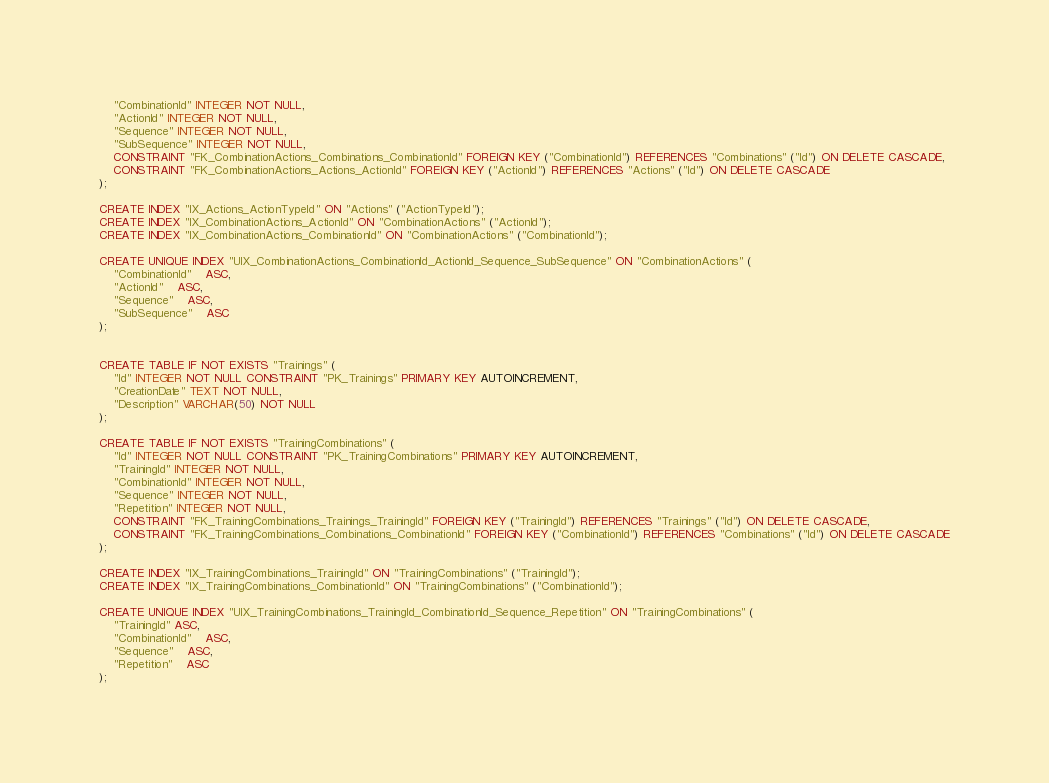<code> <loc_0><loc_0><loc_500><loc_500><_SQL_>    "CombinationId" INTEGER NOT NULL,
    "ActionId" INTEGER NOT NULL,
    "Sequence" INTEGER NOT NULL,
    "SubSequence" INTEGER NOT NULL,
    CONSTRAINT "FK_CombinationActions_Combinations_CombinationId" FOREIGN KEY ("CombinationId") REFERENCES "Combinations" ("Id") ON DELETE CASCADE,
    CONSTRAINT "FK_CombinationActions_Actions_ActionId" FOREIGN KEY ("ActionId") REFERENCES "Actions" ("Id") ON DELETE CASCADE
);

CREATE INDEX "IX_Actions_ActionTypeId" ON "Actions" ("ActionTypeId");
CREATE INDEX "IX_CombinationActions_ActionId" ON "CombinationActions" ("ActionId");
CREATE INDEX "IX_CombinationActions_CombinationId" ON "CombinationActions" ("CombinationId");

CREATE UNIQUE INDEX "UIX_CombinationActions_CombinationId_ActionId_Sequence_SubSequence" ON "CombinationActions" (
	"CombinationId"	ASC,
	"ActionId"	ASC,
	"Sequence"	ASC,
	"SubSequence"	ASC
);


CREATE TABLE IF NOT EXISTS "Trainings" (
    "Id" INTEGER NOT NULL CONSTRAINT "PK_Trainings" PRIMARY KEY AUTOINCREMENT,
    "CreationDate" TEXT NOT NULL,
    "Description" VARCHAR(50) NOT NULL
);

CREATE TABLE IF NOT EXISTS "TrainingCombinations" (
    "Id" INTEGER NOT NULL CONSTRAINT "PK_TrainingCombinations" PRIMARY KEY AUTOINCREMENT,
    "TrainingId" INTEGER NOT NULL,
    "CombinationId" INTEGER NOT NULL,
    "Sequence" INTEGER NOT NULL,
    "Repetition" INTEGER NOT NULL,
    CONSTRAINT "FK_TrainingCombinations_Trainings_TrainingId" FOREIGN KEY ("TrainingId") REFERENCES "Trainings" ("Id") ON DELETE CASCADE,
    CONSTRAINT "FK_TrainingCombinations_Combinations_CombinationId" FOREIGN KEY ("CombinationId") REFERENCES "Combinations" ("Id") ON DELETE CASCADE
);

CREATE INDEX "IX_TrainingCombinations_TrainingId" ON "TrainingCombinations" ("TrainingId");
CREATE INDEX "IX_TrainingCombinations_CombinationId" ON "TrainingCombinations" ("CombinationId");

CREATE UNIQUE INDEX "UIX_TrainingCombinations_TrainingId_CombinationId_Sequence_Repetition" ON "TrainingCombinations" (
	"TrainingId" ASC,
	"CombinationId"	ASC,
	"Sequence"	ASC,
    "Repetition"	ASC
);
</code> 